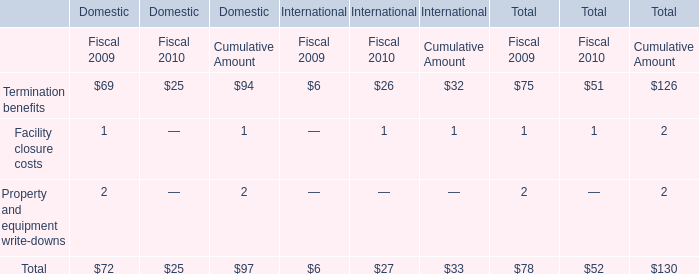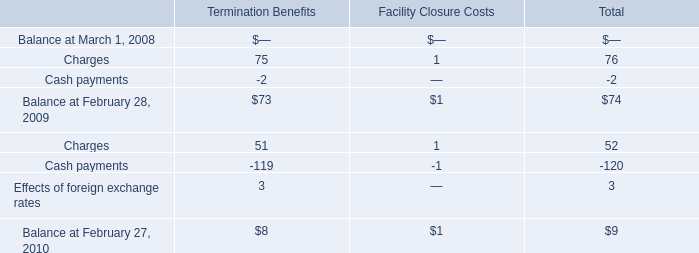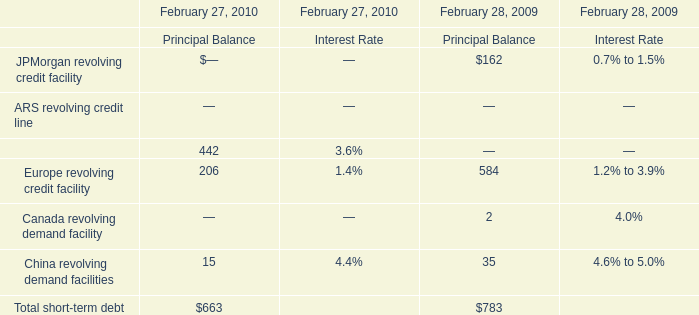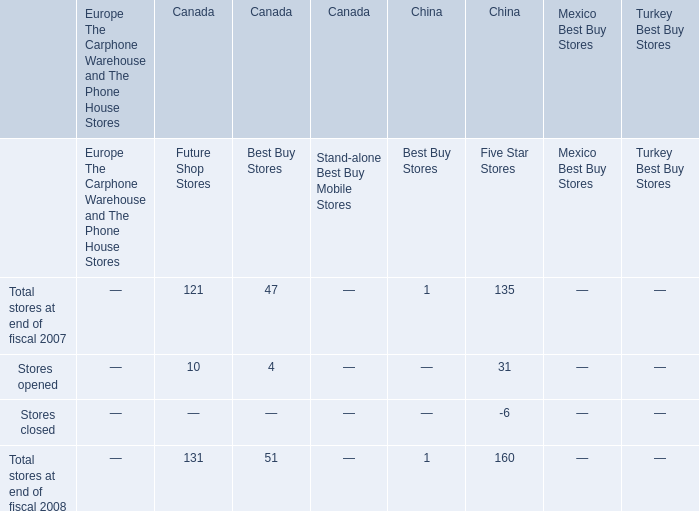In what year is Charges for Termination Benefits higher? 
Answer: 2008. 